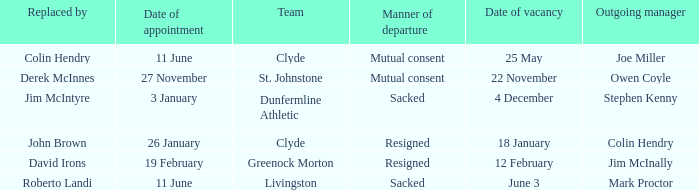Tell me the manner of departure for 3 january date of appointment Sacked. 